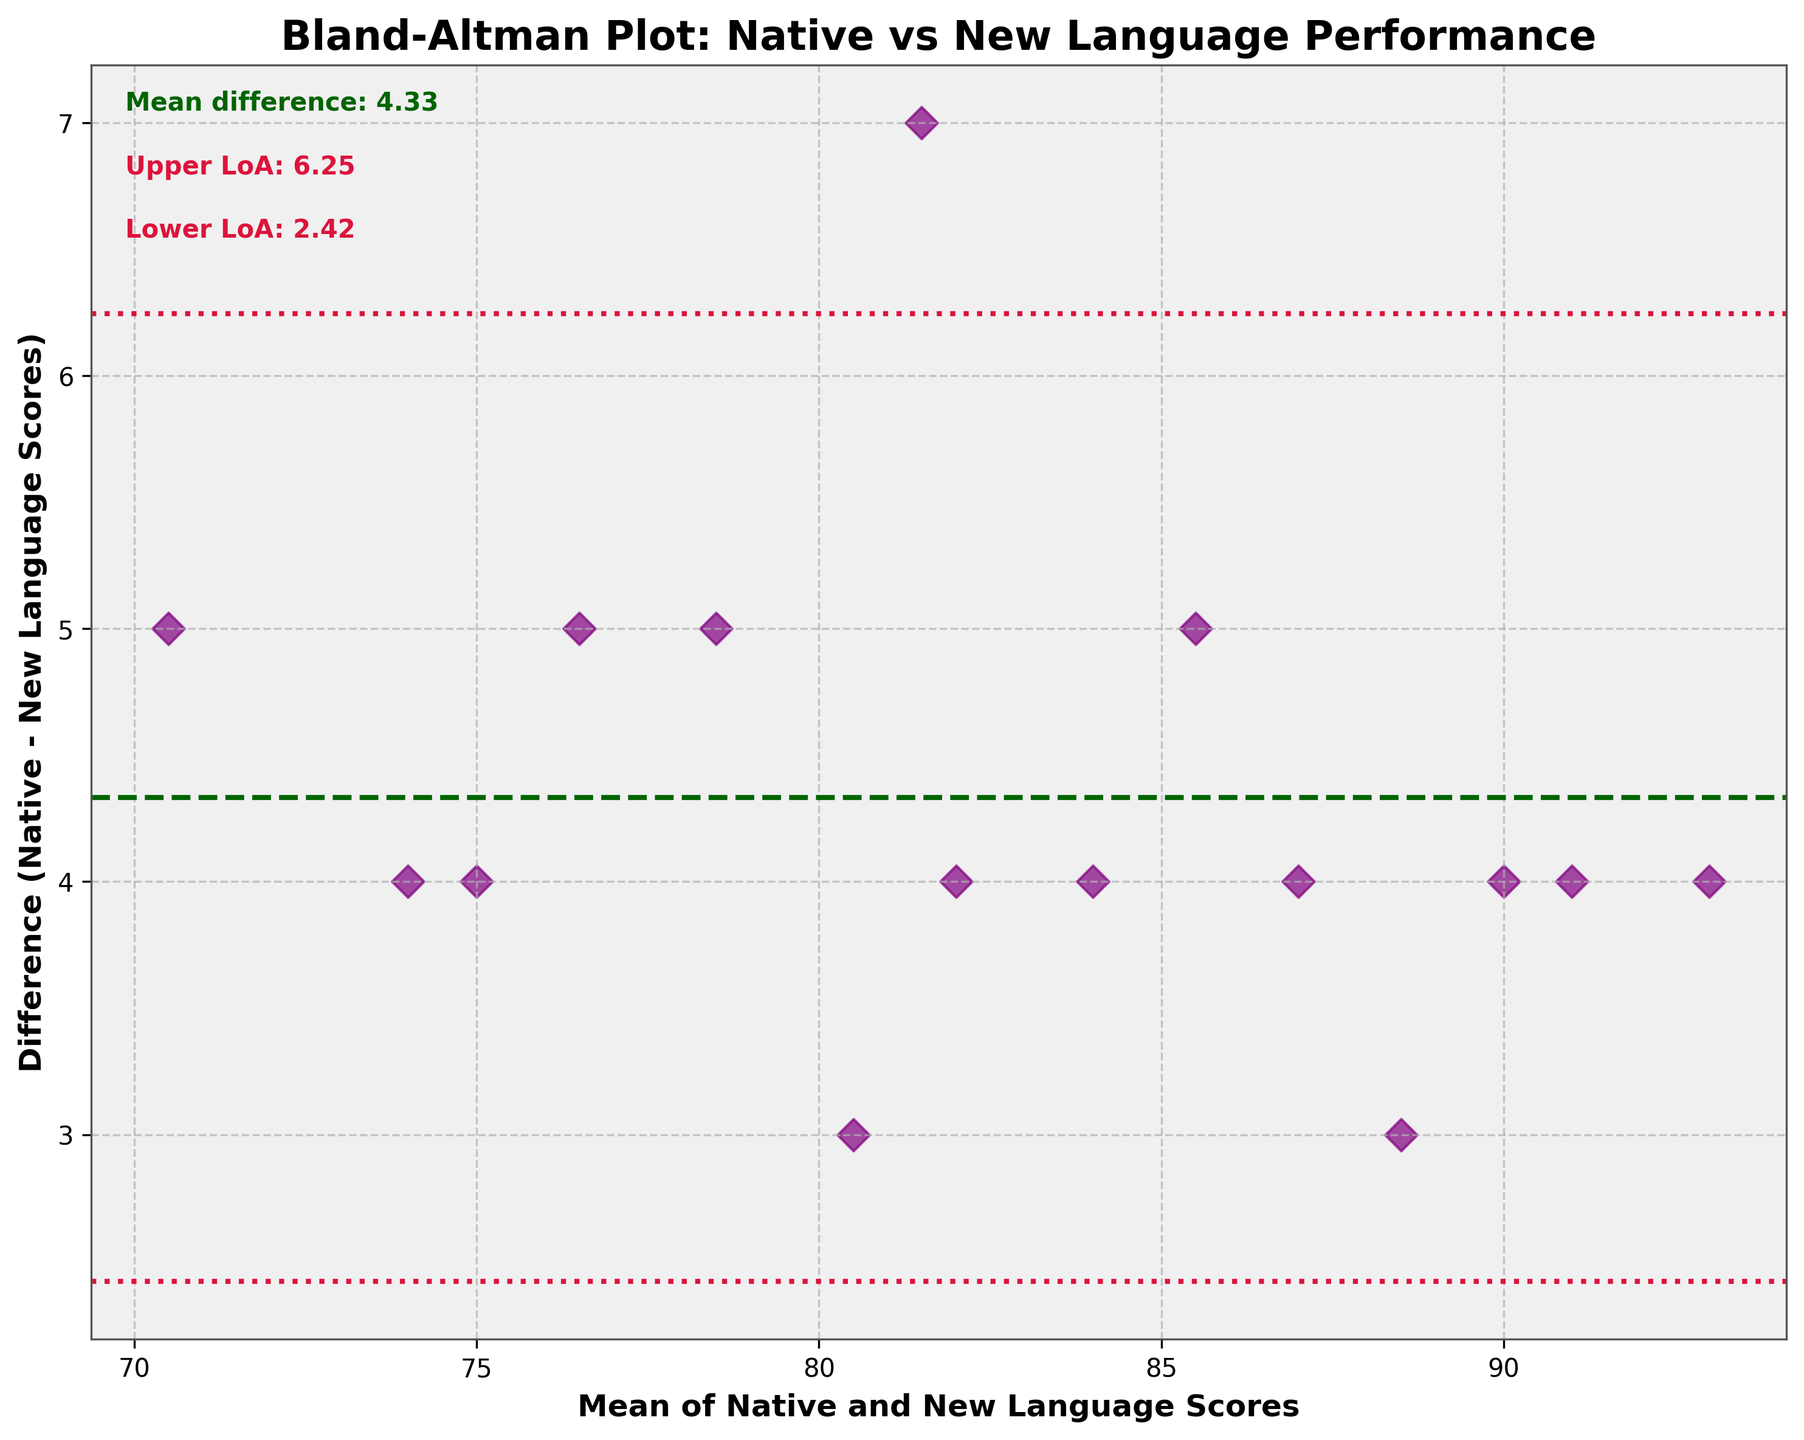What is the title of the plot? The title is located at the top of the figure and provides insight into the comparison being analyzed.
Answer: Bland-Altman Plot: Native vs New Language Performance What do the x-axis and y-axis represent? The axes labels tell us what is being measured. The x-axis represents the mean of native and new language scores, and the y-axis represents the difference between these scores.
Answer: The x-axis represents the mean of Native and New Language Scores, and the y-axis represents the difference (Native - New Language Scores) What is the mean difference between the native and new language scores? The mean difference is depicted as a horizontal line on the plot and is also noted in the text on the plot.
Answer: The mean difference is 4.00 What are the limits of agreement? The limits of agreement are the upper and lower bounds where most differences between two measurements fall. They are shown as dotted lines and noted on the plot. These are calculated as mean difference ± 1.96 * standard deviation.
Answer: The upper limit is 6.51 and the lower limit is 1.49 Which student has the highest mean score? Locate the data point farthest to the right on the x-axis, which represents the highest mean score.
Answer: Omar What is the mean score for student with the lowest observed difference between scores? First, locate the point closest to the x-axis (y = 0) on the plot, then find its mean score on the x-axis.
Answer: Omar with a mean score of 93 How many students scored higher in the new language compared to their native language? Count the data points below the x-axis, since a negative difference indicates a higher new language score.
Answer: None What is the range of mean scores in the plot? The range is found by subtracting the smallest mean score value from the largest mean score value.
Answer: The range is 71 (lowest) to 93 (highest) Which student has the largest difference between their native and new language scores? Identify the data point with the highest vertical distance from the x-axis (either positively or negatively).
Answer: Amira Do any students fall outside the limits of agreement? Check if there are any data points beyond the upper or lower dotted lines, which represent the limits of agreement.
Answer: No 